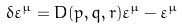Convert formula to latex. <formula><loc_0><loc_0><loc_500><loc_500>\delta \varepsilon ^ { \mu } = D ( p , q , r ) \varepsilon ^ { \mu } - { \varepsilon } ^ { \mu }</formula> 